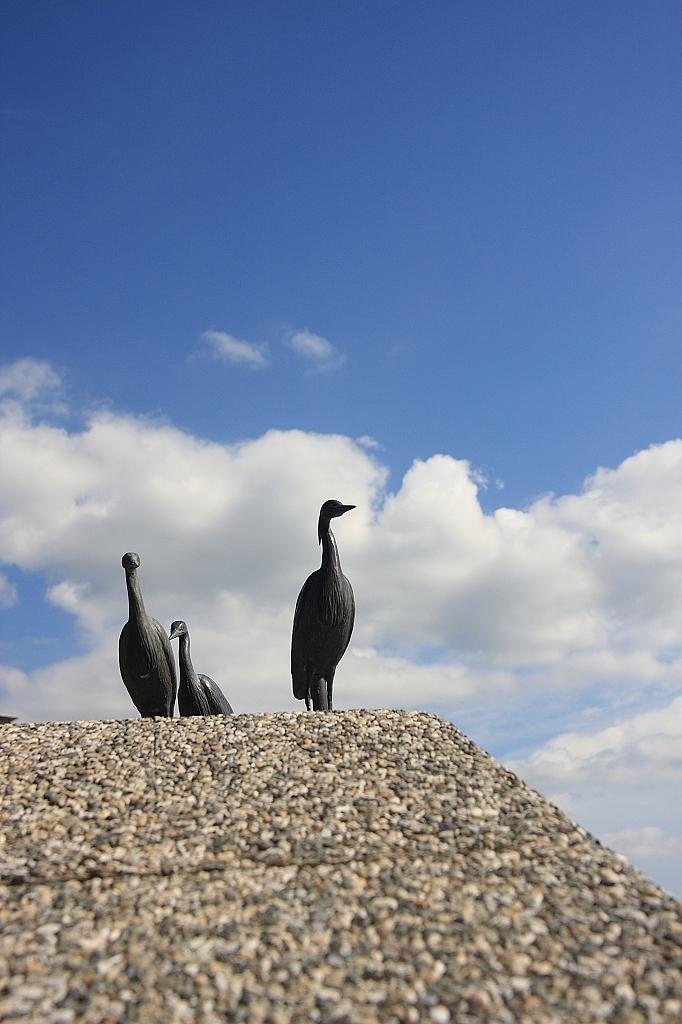What animals can be seen in the image? There are birds standing on the ground in the image. What type of surface is visible at the bottom of the image? Tiles are visible at the bottom of the image. What is visible at the top of the image? The sky is visible at the top of the image. What can be seen in the sky? Clouds are present in the sky. What type of notebook is being used by the person in the image? There is no person present in the image, and therefore no notebook can be observed. 